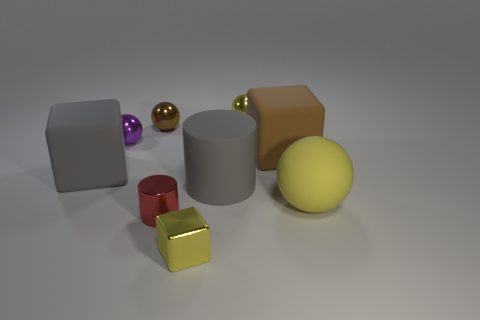Subtract all gray cylinders. How many yellow balls are left? 2 Subtract all big rubber blocks. How many blocks are left? 1 Subtract 2 spheres. How many spheres are left? 2 Subtract all brown balls. How many balls are left? 3 Subtract all cubes. How many objects are left? 6 Subtract all yellow balls. Subtract all brown cubes. How many balls are left? 2 Subtract all big gray rubber cylinders. Subtract all yellow rubber spheres. How many objects are left? 7 Add 1 small red metal cylinders. How many small red metal cylinders are left? 2 Add 1 large blue matte things. How many large blue matte things exist? 1 Subtract 1 gray cylinders. How many objects are left? 8 